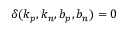Convert formula to latex. <formula><loc_0><loc_0><loc_500><loc_500>\delta ( k _ { p } , k _ { n } , b _ { p } , b _ { n } ) = 0</formula> 